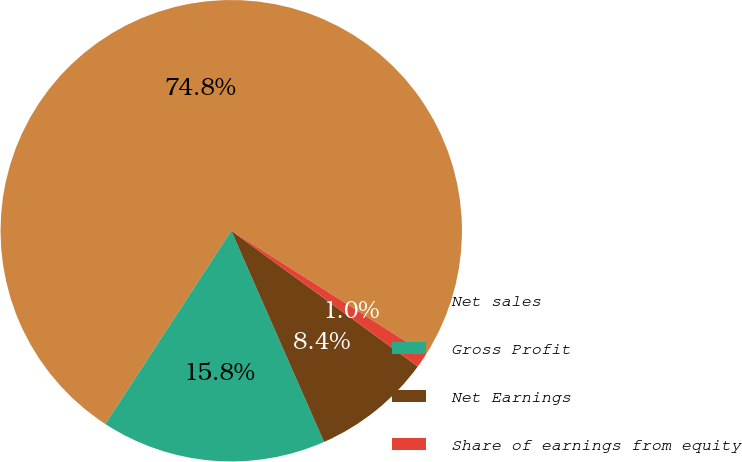Convert chart. <chart><loc_0><loc_0><loc_500><loc_500><pie_chart><fcel>Net sales<fcel>Gross Profit<fcel>Net Earnings<fcel>Share of earnings from equity<nl><fcel>74.81%<fcel>15.78%<fcel>8.4%<fcel>1.02%<nl></chart> 